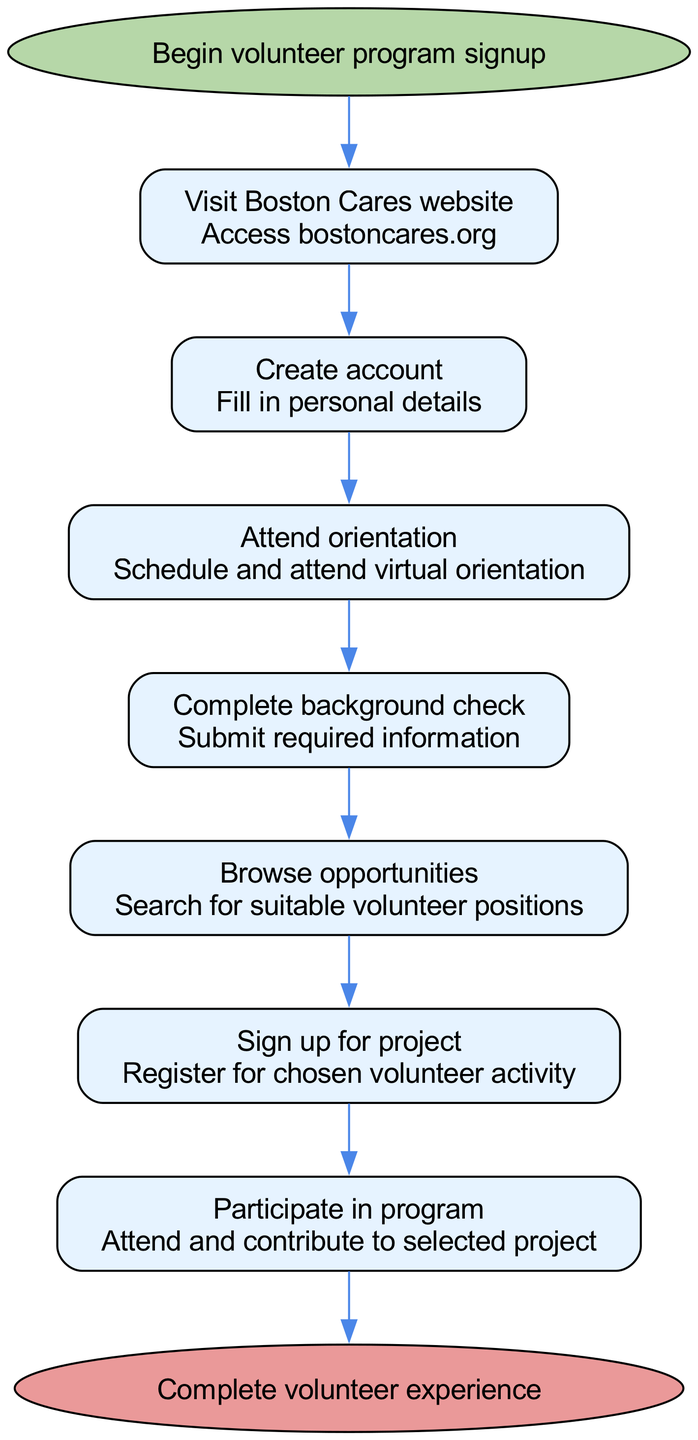What is the first step in the volunteer program signup? The first step in the diagram is "Visit Boston Cares website," which is the initial action that needs to be taken to start the signup process.
Answer: Visit Boston Cares website How many steps are there in the process? Counting all the steps listed between the start and end nodes, there are seven distinct steps in the process of signing up and participating in the volunteer program.
Answer: Seven What do you need to do after creating an account? According to the flow, after creating an account, the next required action is to "Attend orientation," meaning you must schedule and attend a virtual orientation after setting up your account.
Answer: Attend orientation Which step comes right before participating in the program? The step that comes immediately before "Participate in program" is "Sign up for project," indicating that you need to register for a chosen volunteer activity before you can participate.
Answer: Sign up for project What is the final step of the process? The last node in the flowchart indicates that the final step of the process is to "Complete volunteer experience," marking the conclusion of the signup and participation journey in the volunteer program.
Answer: Complete volunteer experience If a candidate skips the orientation, what is the consequence in the flow? Skipping the orientation would mean missing a mandatory step in the process after creating an account, which would likely prevent you from moving on to the next step, "Complete background check."
Answer: Cannot proceed to next step 